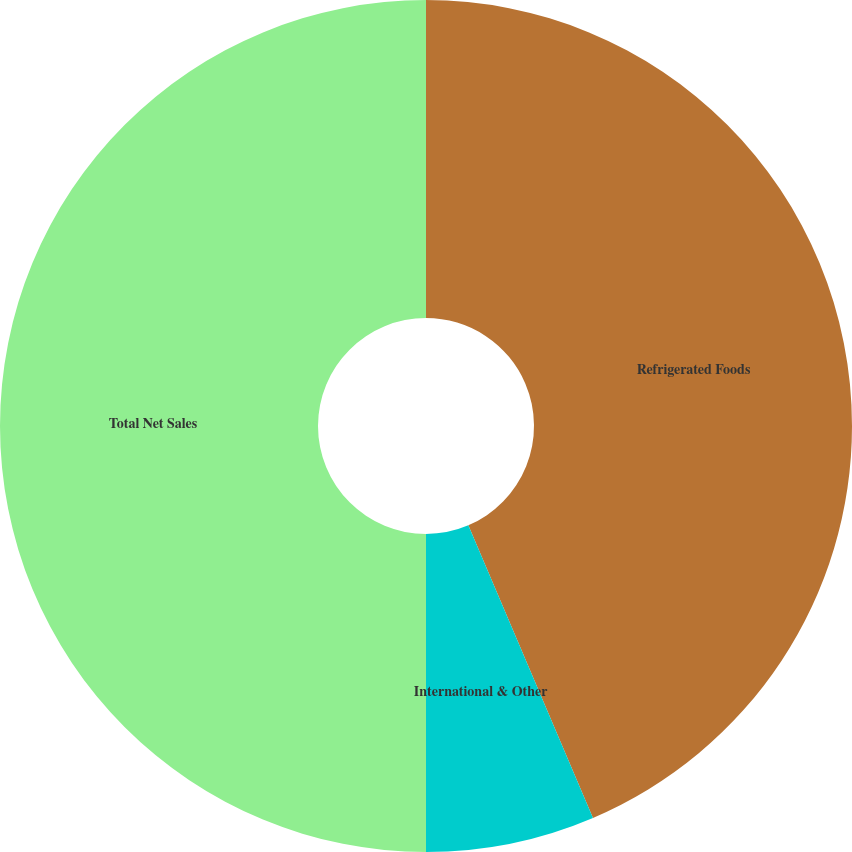<chart> <loc_0><loc_0><loc_500><loc_500><pie_chart><fcel>Refrigerated Foods<fcel>International & Other<fcel>Total Net Sales<nl><fcel>43.59%<fcel>6.41%<fcel>50.0%<nl></chart> 